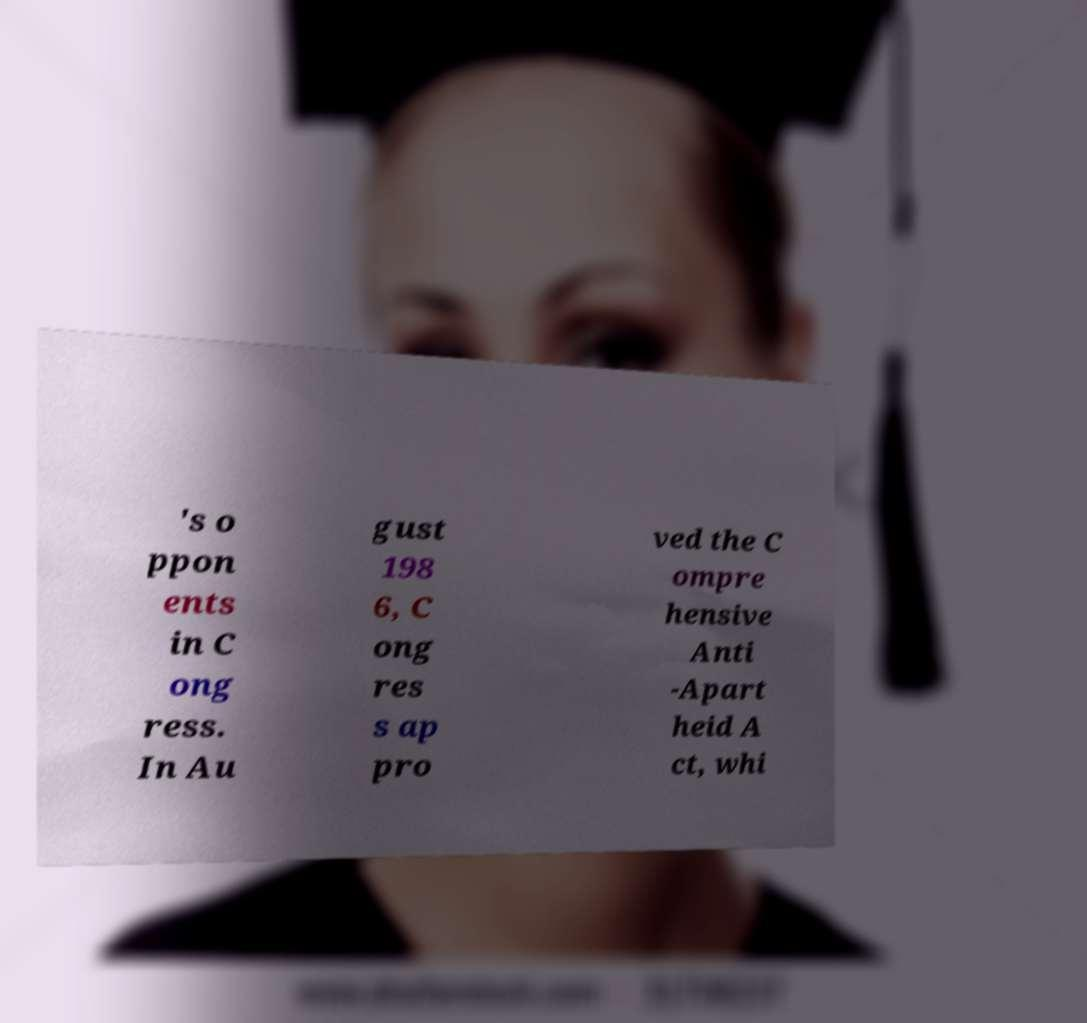For documentation purposes, I need the text within this image transcribed. Could you provide that? 's o ppon ents in C ong ress. In Au gust 198 6, C ong res s ap pro ved the C ompre hensive Anti -Apart heid A ct, whi 